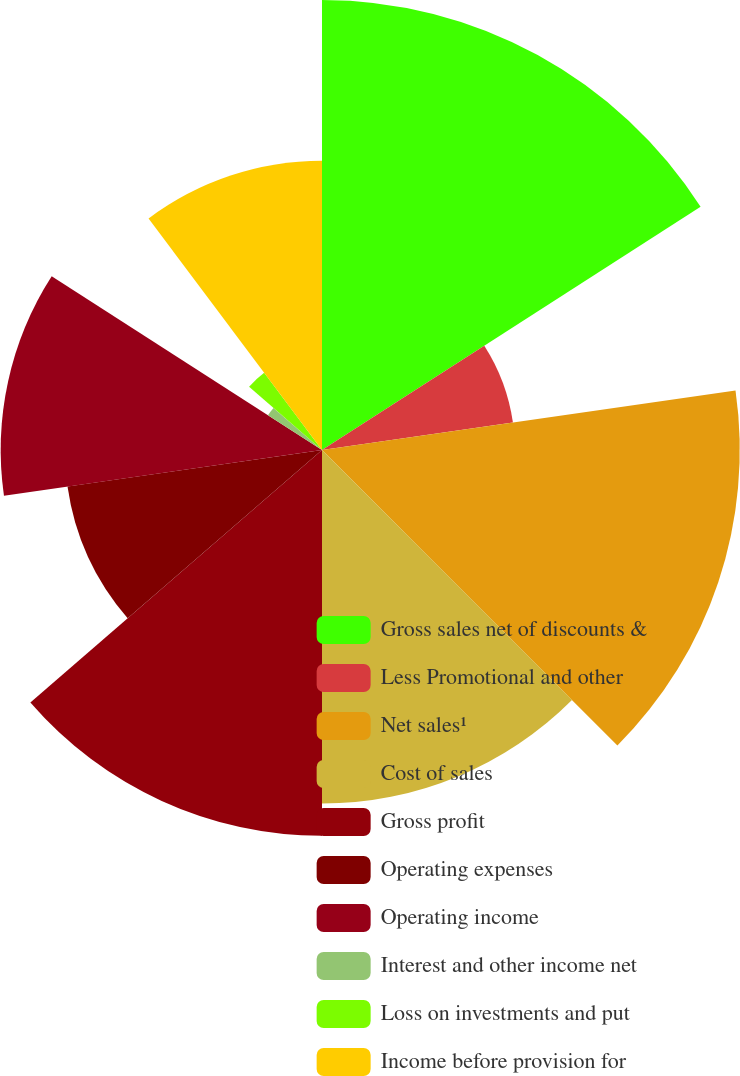Convert chart. <chart><loc_0><loc_0><loc_500><loc_500><pie_chart><fcel>Gross sales net of discounts &<fcel>Less Promotional and other<fcel>Net sales¹<fcel>Cost of sales<fcel>Gross profit<fcel>Operating expenses<fcel>Operating income<fcel>Interest and other income net<fcel>Loss on investments and put<fcel>Income before provision for<nl><fcel>15.91%<fcel>6.82%<fcel>14.77%<fcel>12.5%<fcel>13.64%<fcel>9.09%<fcel>11.36%<fcel>2.27%<fcel>3.41%<fcel>10.23%<nl></chart> 